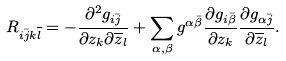Convert formula to latex. <formula><loc_0><loc_0><loc_500><loc_500>R _ { i \bar { j } k \overline { l } } = - \frac { \partial ^ { 2 } g _ { i \bar { j } } } { \partial z _ { k } \partial \overline { z } _ { l } } + \sum _ { \alpha , \beta } g ^ { \alpha \bar { \beta } } \frac { \partial g _ { i \bar { \beta } } } { \partial z _ { k } } \frac { \partial g _ { \alpha \bar { j } } } { \partial \overline { z } _ { l } } .</formula> 